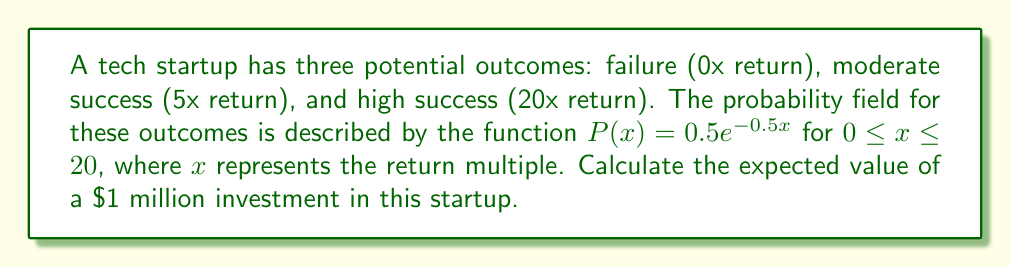Show me your answer to this math problem. To solve this problem, we need to follow these steps:

1) The expected value is calculated by integrating the product of the outcome (x) and its probability density function (P(x)) over the given range:

   $E[X] = \int_0^{20} xP(x)dx$

2) Substituting the given probability density function:

   $E[X] = \int_0^{20} x(0.5e^{-0.5x})dx$

3) This integral can be solved using integration by parts. Let $u = x$ and $dv = 0.5e^{-0.5x}dx$. Then $du = dx$ and $v = -e^{-0.5x}$:

   $E[X] = [-xe^{-0.5x}]_0^{20} + \int_0^{20} e^{-0.5x}dx$

4) Evaluating the first term:

   $[-xe^{-0.5x}]_0^{20} = -20e^{-10} - 0 = -20e^{-10}$

5) Solving the remaining integral:

   $\int_0^{20} e^{-0.5x}dx = [-2e^{-0.5x}]_0^{20} = -2e^{-10} + 2$

6) Combining the results:

   $E[X] = -20e^{-10} + (-2e^{-10} + 2) = 2 - 22e^{-10}$

7) This gives us the expected return multiple. To get the expected value of a $1 million investment, we multiply by 1,000,000:

   $Expected Value = (2 - 22e^{-10}) * 1,000,000 \approx 1,999,955$
Answer: $1,999,955 